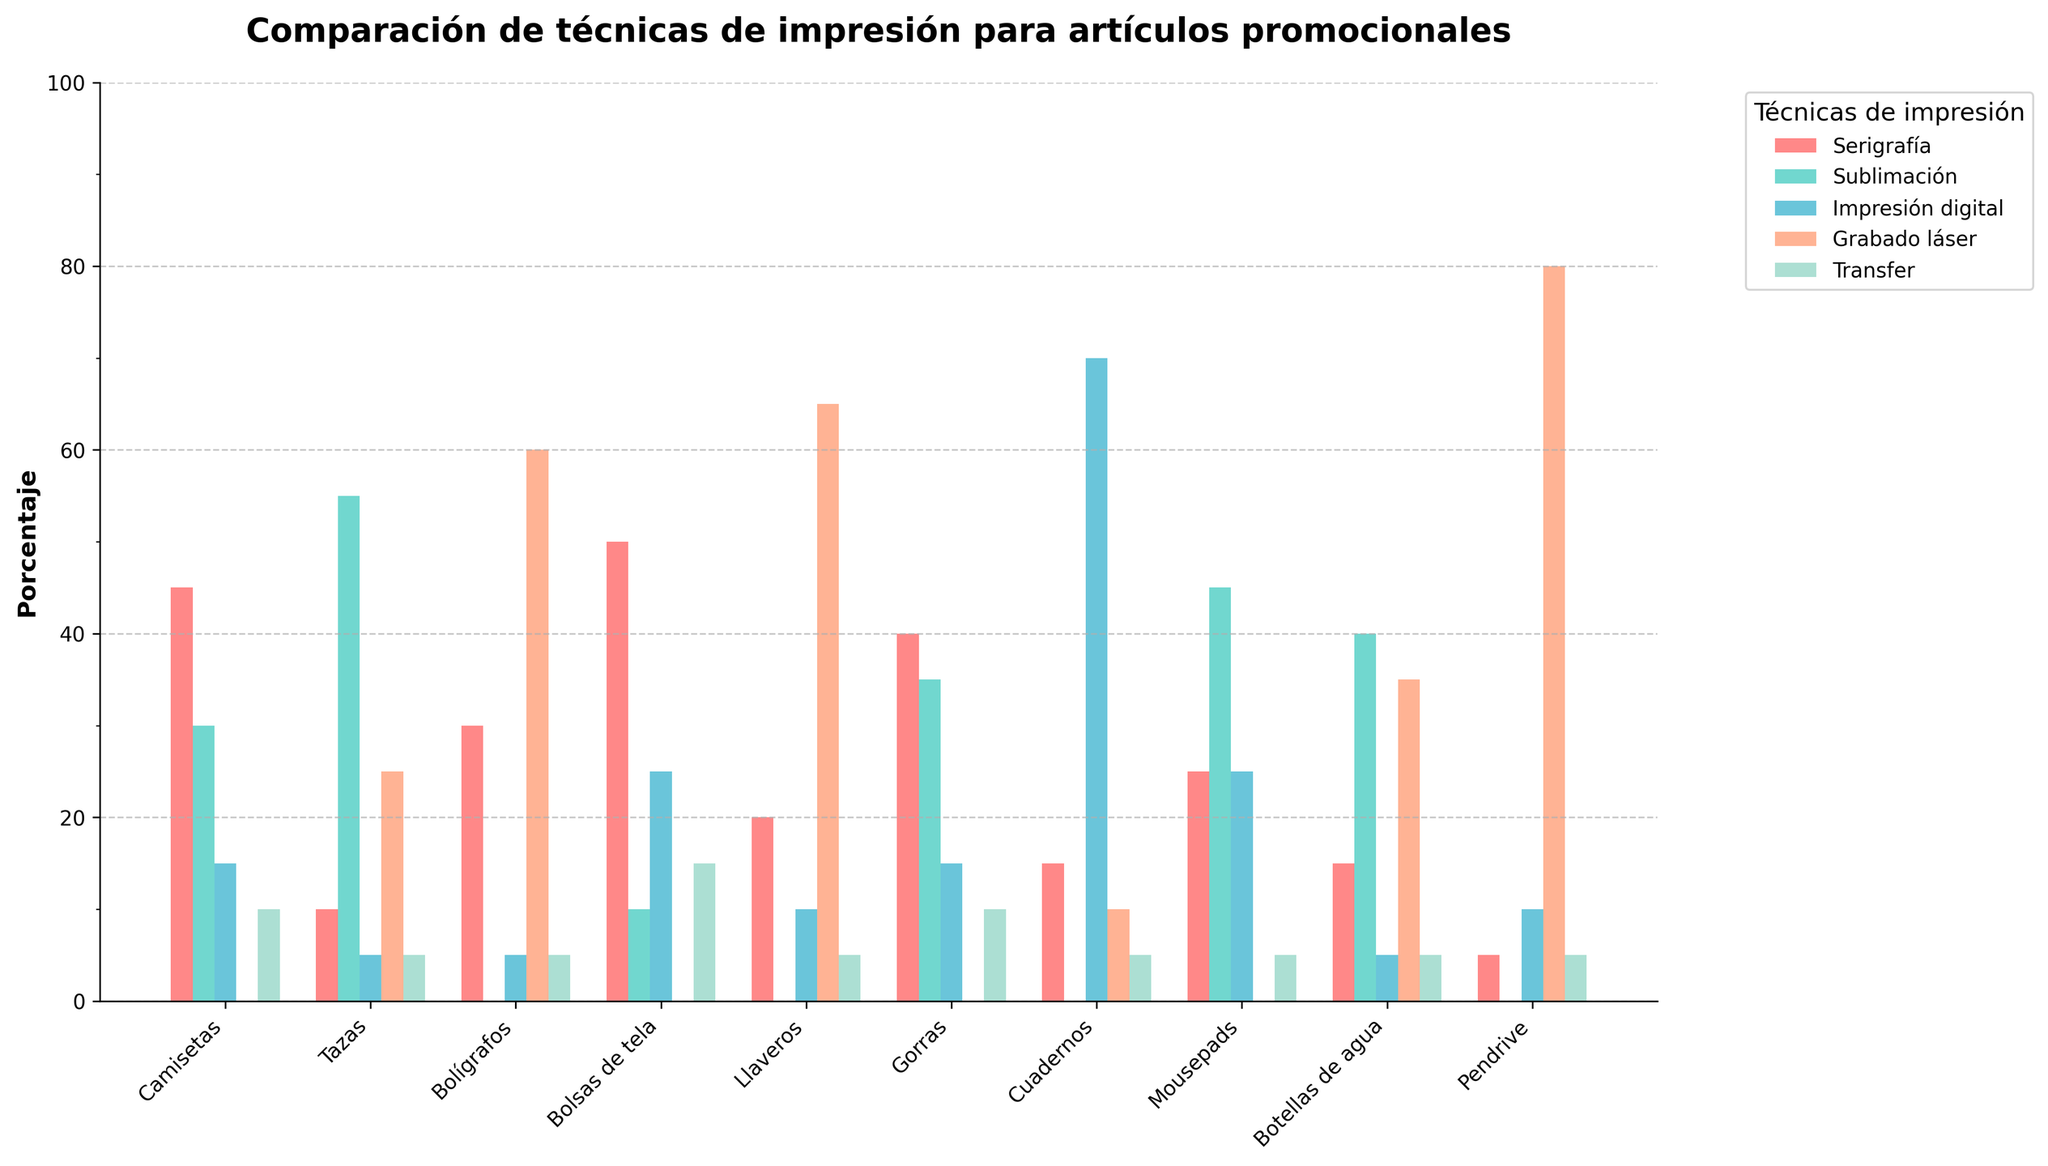¿Cómo se compara la popularidad de Grabado láser entre llaveros y tazas? Primero, observa las alturas de las barras correspondientes a Grabado láser para llaveros y tazas. La altura de la barra para llaveros en Grabado láser es mayor que la de las tazas. Grabado láser tiene 65% para llaveros y 25% para tazas.
Answer: Llaveros (65%) es más popular que Tazas (25%) ¿Qué técnica de impresión tiene la menor cantidad de solicitudes para camisetas? Busca la barra más baja en el grupo de camisetas. La técnica de Grabado láser no tiene ninguna barra en las camisetas, lo cual implica 0 solicitudes.
Answer: Grabado láser ¿Cuál es la técnica de impresión más solicitada en cuadernos? Identifica la barra más alta en el grupo de cuadernos. La barra pertenece a Impresión digital, que tiene la mayor altura en ese grupo.
Answer: Impresión digital (70%) Si sumamos las solicitudes de Impresión digital y Serigrafía para tazas, ¿cuál es el total? Agrega los porcentajes de Impresión digital (5%) y Serigrafía (10%) para tazas.
Answer: 15% ¿Cuáles son las dos técnicas de impresión más utilizadas para gorras y cuál es la diferencia entre ellas? Observa las dos barras más altas en el grupo de gorras. Serigrafía (40%) y Sublimación (35%) son las más usadas. La diferencia es 40% - 35%.
Answer: Serigrafía (40%), Sublimación (35%), diferencia de 5% ¿Qué artículo promocional tiene la mayor preferencia por la técnica de Transfer? Identifica la barra más alta en la sección dedicada a Transfer. Bolsas de tela tiene una barra de 15% en Transfer.
Answer: Bolsas de tela ¿Cuál técnica de impresión muestra una mayor variabilidad en popularidad entre los diferentes artículos promocionales? Compara la altura de las barras correspondientes a cada técnica a través de todos los artículos. Grabado láser varía de 0% a 80%, mientras que otras técnicas tienen un rango menor de variación.
Answer: Grabado láser ¿Cuál es el porcentaje promedio de solicitudes para la técnica de Sublimación en todos los artículos promocionales? Suma los valores de Sublimación (30+55+0+10+0+35+0+45+40+0) y divide entre el número de artículos (10). (30+55+0+10+0+35+0+45+40+0)/10 = 21.5%
Answer: 21.5% ¿Qué técnica de impresión tiene consistentemente baja popularidad (por debajo de 20%) en la mayoría de los artículos promocionales? Examina las técnicas que tienen la mayoría de sus barras bajo 20%. Transfer comúnmente tiene valores bajos en la mayoría de los artículos.
Answer: Transfer 